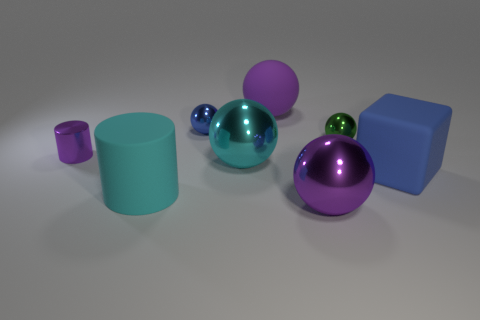Is there any other thing that has the same shape as the big blue rubber thing?
Ensure brevity in your answer.  No. There is a sphere behind the blue metal sphere; what is its material?
Keep it short and to the point. Rubber. Are there any big blue objects behind the big blue block?
Provide a succinct answer. No. What shape is the cyan rubber object?
Offer a very short reply. Cylinder. How many things are either large rubber things that are on the right side of the big purple metallic sphere or large red rubber things?
Your response must be concise. 1. How many other objects are the same color as the big matte cylinder?
Your answer should be very brief. 1. Is the color of the big rubber ball the same as the small metal thing that is in front of the tiny green ball?
Give a very brief answer. Yes. What is the color of the other small metal object that is the same shape as the green metal object?
Provide a succinct answer. Blue. Does the large cyan cylinder have the same material as the big purple sphere that is in front of the cyan sphere?
Your response must be concise. No. The large matte cylinder has what color?
Ensure brevity in your answer.  Cyan. 